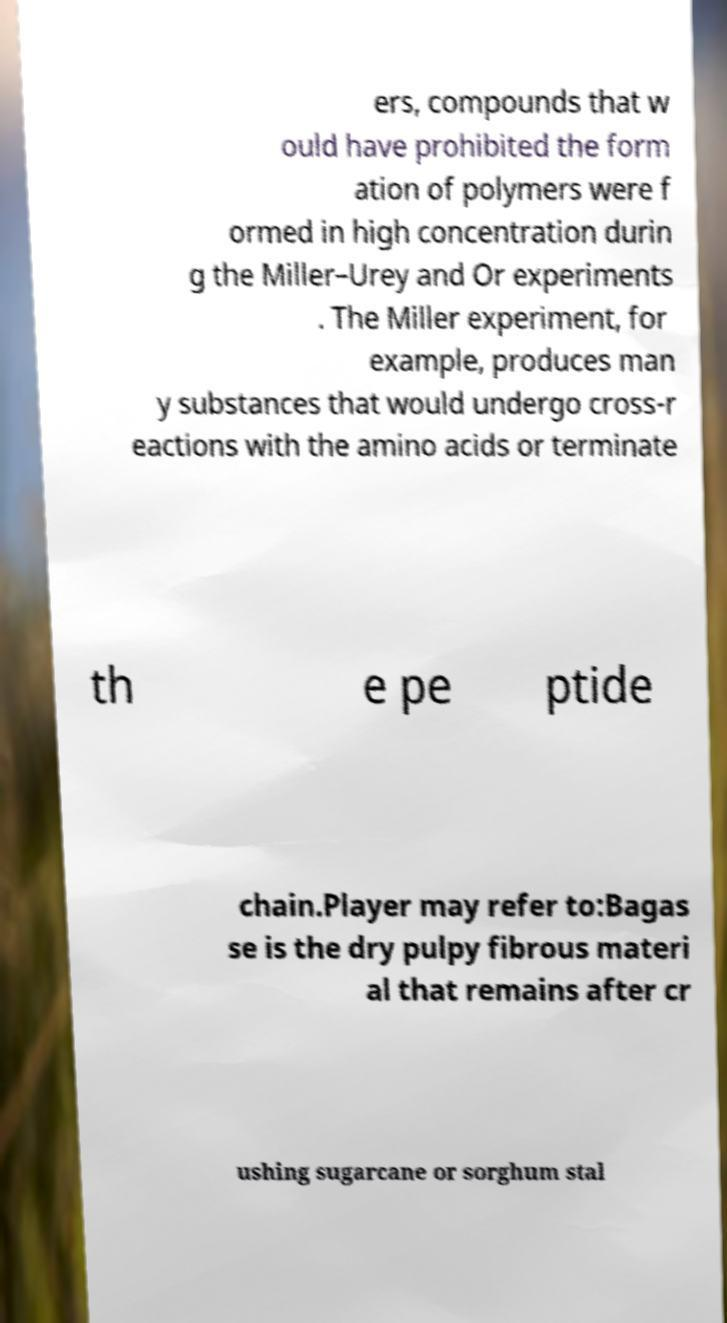Can you read and provide the text displayed in the image?This photo seems to have some interesting text. Can you extract and type it out for me? ers, compounds that w ould have prohibited the form ation of polymers were f ormed in high concentration durin g the Miller–Urey and Or experiments . The Miller experiment, for example, produces man y substances that would undergo cross-r eactions with the amino acids or terminate th e pe ptide chain.Player may refer to:Bagas se is the dry pulpy fibrous materi al that remains after cr ushing sugarcane or sorghum stal 